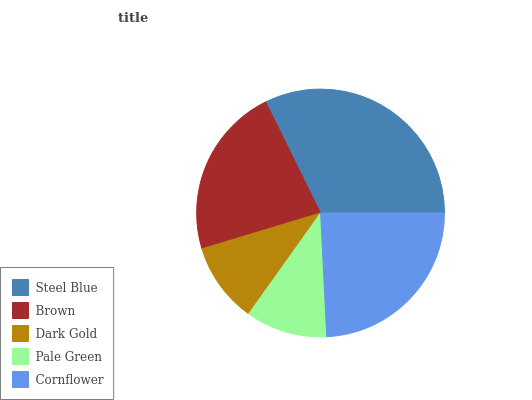Is Dark Gold the minimum?
Answer yes or no. Yes. Is Steel Blue the maximum?
Answer yes or no. Yes. Is Brown the minimum?
Answer yes or no. No. Is Brown the maximum?
Answer yes or no. No. Is Steel Blue greater than Brown?
Answer yes or no. Yes. Is Brown less than Steel Blue?
Answer yes or no. Yes. Is Brown greater than Steel Blue?
Answer yes or no. No. Is Steel Blue less than Brown?
Answer yes or no. No. Is Brown the high median?
Answer yes or no. Yes. Is Brown the low median?
Answer yes or no. Yes. Is Pale Green the high median?
Answer yes or no. No. Is Cornflower the low median?
Answer yes or no. No. 